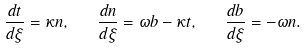<formula> <loc_0><loc_0><loc_500><loc_500>\frac { d { t } } { d \xi } = \kappa { n } , \quad \frac { d { n } } { d \xi } = \omega { b } - \kappa { t } , \quad \frac { d { b } } { d \xi } = - \omega { n } .</formula> 